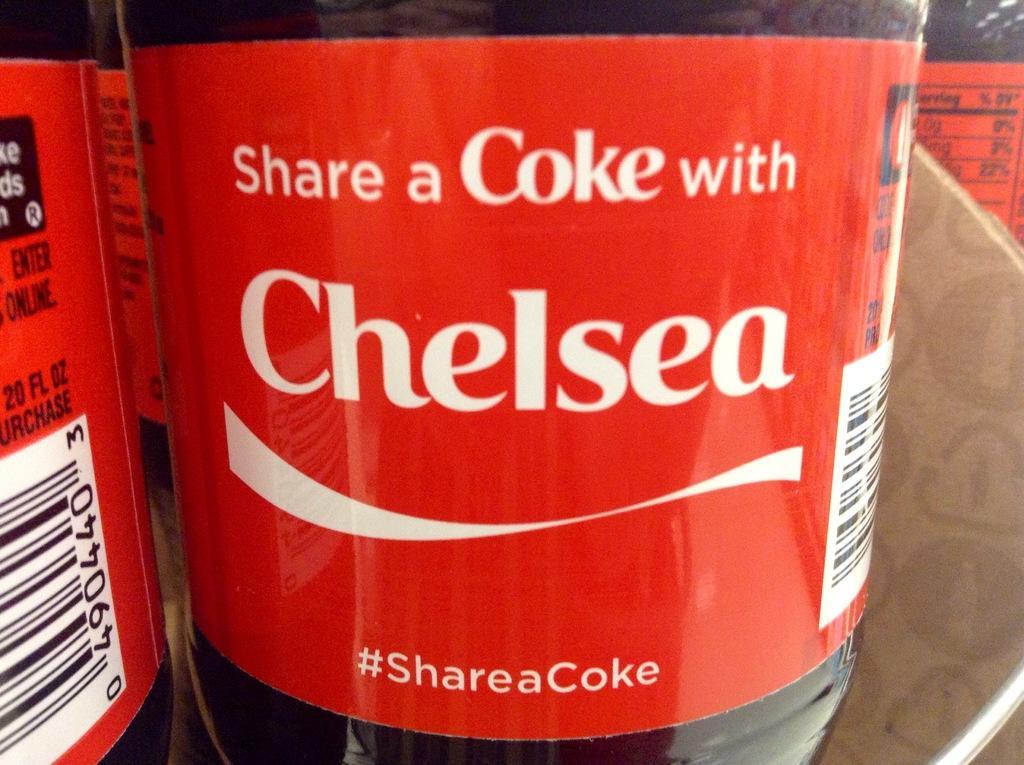Could you give a brief overview of what you see in this image? In this image, I can see bottles kept maybe in racks. This picture might be taken in a shop. 